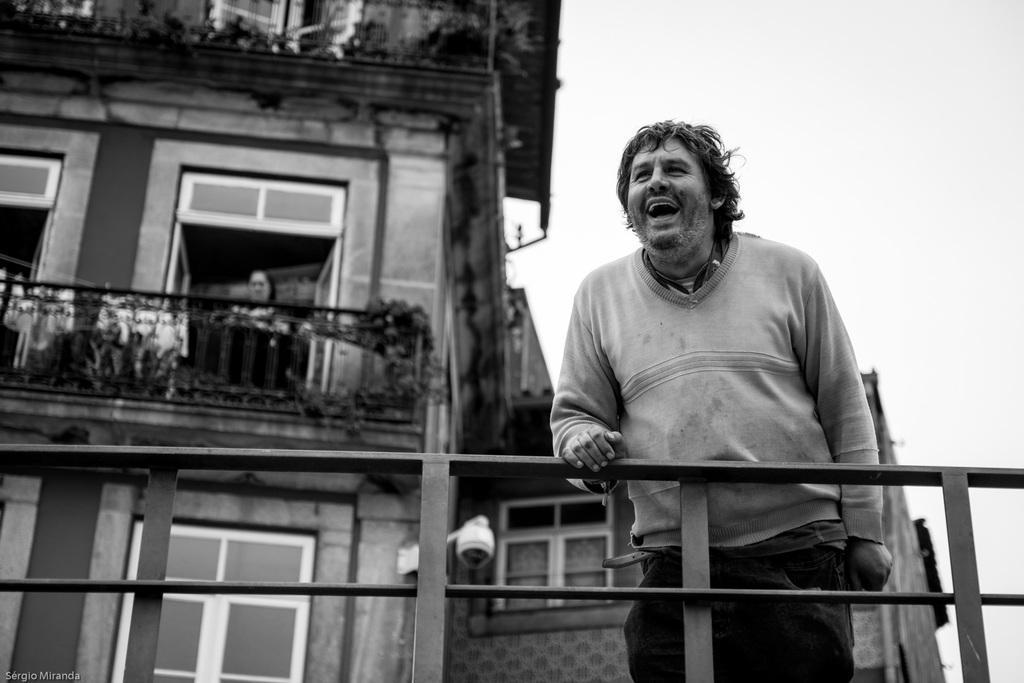Describe this image in one or two sentences. This is a black and white image. There is a person standing near a railing. In the background of the image there is a building. There are windows. There is a woman standing near a window. 